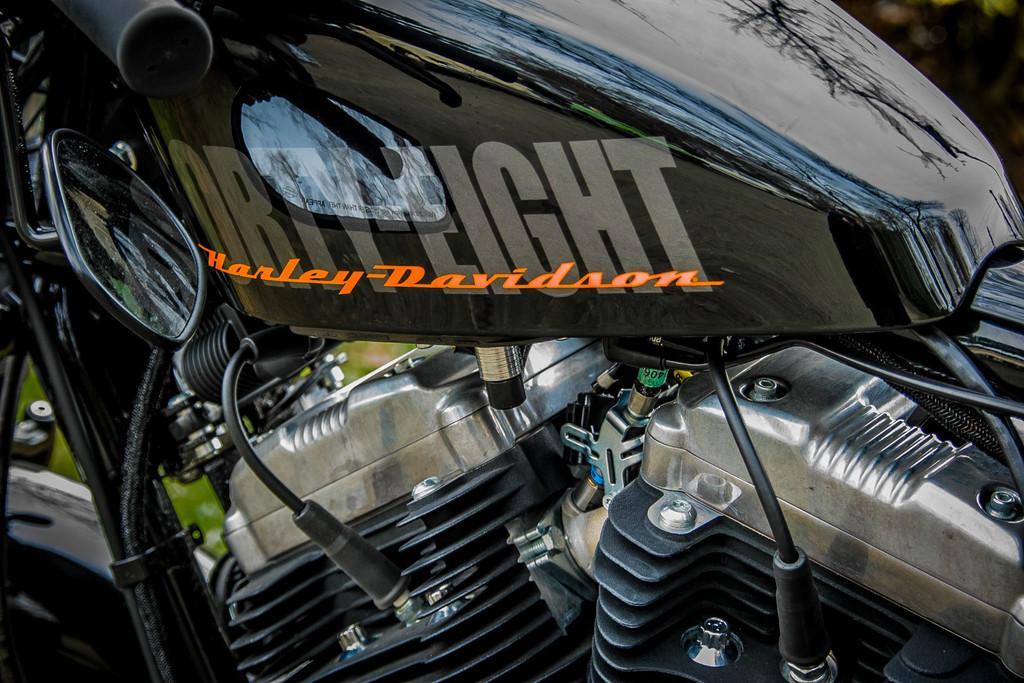In one or two sentences, can you explain what this image depicts? Here we can see a black color bike and its engine parts and cables. In the background the image is blur. 